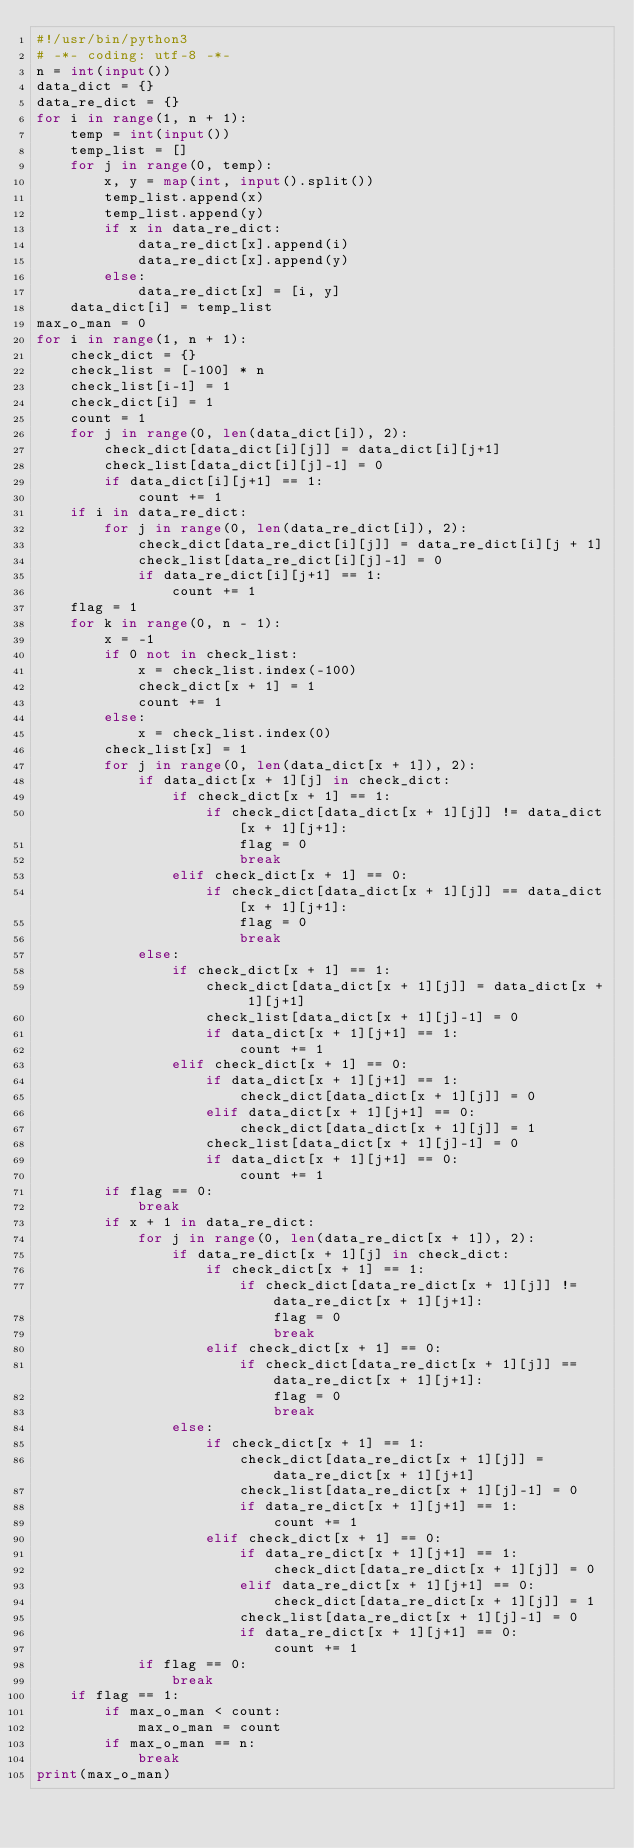<code> <loc_0><loc_0><loc_500><loc_500><_Python_>#!/usr/bin/python3
# -*- coding: utf-8 -*-
n = int(input())
data_dict = {}
data_re_dict = {}
for i in range(1, n + 1):
    temp = int(input())
    temp_list = []
    for j in range(0, temp):
        x, y = map(int, input().split())
        temp_list.append(x)
        temp_list.append(y)
        if x in data_re_dict:
            data_re_dict[x].append(i)
            data_re_dict[x].append(y)
        else:
            data_re_dict[x] = [i, y]
    data_dict[i] = temp_list
max_o_man = 0
for i in range(1, n + 1):
    check_dict = {}
    check_list = [-100] * n
    check_list[i-1] = 1
    check_dict[i] = 1
    count = 1
    for j in range(0, len(data_dict[i]), 2):
        check_dict[data_dict[i][j]] = data_dict[i][j+1]
        check_list[data_dict[i][j]-1] = 0
        if data_dict[i][j+1] == 1:
            count += 1
    if i in data_re_dict:
        for j in range(0, len(data_re_dict[i]), 2):
            check_dict[data_re_dict[i][j]] = data_re_dict[i][j + 1]
            check_list[data_re_dict[i][j]-1] = 0
            if data_re_dict[i][j+1] == 1:
                count += 1
    flag = 1
    for k in range(0, n - 1):
        x = -1
        if 0 not in check_list:
            x = check_list.index(-100)
            check_dict[x + 1] = 1
            count += 1
        else:
            x = check_list.index(0)
        check_list[x] = 1
        for j in range(0, len(data_dict[x + 1]), 2):
            if data_dict[x + 1][j] in check_dict:
                if check_dict[x + 1] == 1:
                    if check_dict[data_dict[x + 1][j]] != data_dict[x + 1][j+1]:
                        flag = 0
                        break
                elif check_dict[x + 1] == 0:
                    if check_dict[data_dict[x + 1][j]] == data_dict[x + 1][j+1]:
                        flag = 0
                        break
            else:
                if check_dict[x + 1] == 1:
                    check_dict[data_dict[x + 1][j]] = data_dict[x + 1][j+1]
                    check_list[data_dict[x + 1][j]-1] = 0
                    if data_dict[x + 1][j+1] == 1:
                        count += 1
                elif check_dict[x + 1] == 0:
                    if data_dict[x + 1][j+1] == 1:
                        check_dict[data_dict[x + 1][j]] = 0
                    elif data_dict[x + 1][j+1] == 0:
                        check_dict[data_dict[x + 1][j]] = 1
                    check_list[data_dict[x + 1][j]-1] = 0
                    if data_dict[x + 1][j+1] == 0:
                        count += 1
        if flag == 0:
            break
        if x + 1 in data_re_dict:
            for j in range(0, len(data_re_dict[x + 1]), 2):
                if data_re_dict[x + 1][j] in check_dict:
                    if check_dict[x + 1] == 1:
                        if check_dict[data_re_dict[x + 1][j]] != data_re_dict[x + 1][j+1]:
                            flag = 0
                            break
                    elif check_dict[x + 1] == 0:
                        if check_dict[data_re_dict[x + 1][j]] == data_re_dict[x + 1][j+1]:
                            flag = 0
                            break
                else:
                    if check_dict[x + 1] == 1:
                        check_dict[data_re_dict[x + 1][j]] = data_re_dict[x + 1][j+1]
                        check_list[data_re_dict[x + 1][j]-1] = 0
                        if data_re_dict[x + 1][j+1] == 1:
                            count += 1
                    elif check_dict[x + 1] == 0:
                        if data_re_dict[x + 1][j+1] == 1:
                            check_dict[data_re_dict[x + 1][j]] = 0
                        elif data_re_dict[x + 1][j+1] == 0:
                            check_dict[data_re_dict[x + 1][j]] = 1
                        check_list[data_re_dict[x + 1][j]-1] = 0
                        if data_re_dict[x + 1][j+1] == 0:
                            count += 1
            if flag == 0:
                break
    if flag == 1:
        if max_o_man < count:
            max_o_man = count
        if max_o_man == n:
            break
print(max_o_man)</code> 